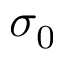<formula> <loc_0><loc_0><loc_500><loc_500>\sigma _ { 0 }</formula> 